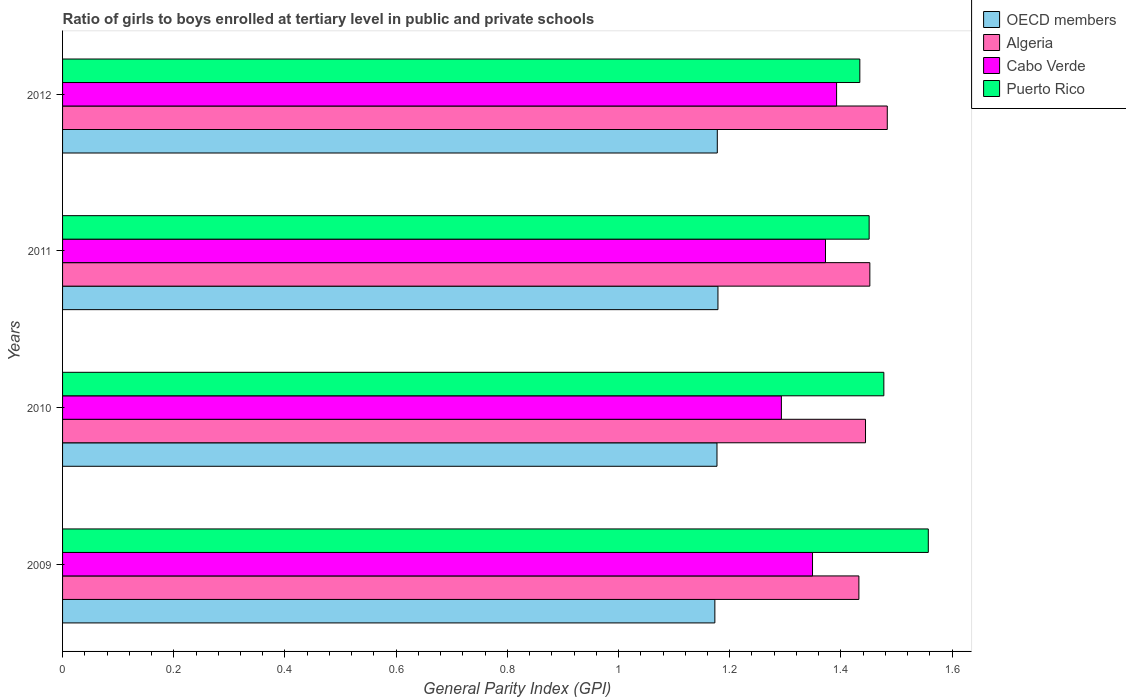How many groups of bars are there?
Give a very brief answer. 4. Are the number of bars on each tick of the Y-axis equal?
Your answer should be very brief. Yes. How many bars are there on the 1st tick from the bottom?
Ensure brevity in your answer.  4. What is the label of the 4th group of bars from the top?
Give a very brief answer. 2009. What is the general parity index in Cabo Verde in 2009?
Your answer should be very brief. 1.35. Across all years, what is the maximum general parity index in Puerto Rico?
Provide a succinct answer. 1.56. Across all years, what is the minimum general parity index in Algeria?
Keep it short and to the point. 1.43. In which year was the general parity index in Puerto Rico minimum?
Make the answer very short. 2012. What is the total general parity index in Algeria in the graph?
Give a very brief answer. 5.81. What is the difference between the general parity index in Puerto Rico in 2010 and that in 2011?
Keep it short and to the point. 0.03. What is the difference between the general parity index in Puerto Rico in 2009 and the general parity index in Cabo Verde in 2011?
Offer a very short reply. 0.18. What is the average general parity index in Puerto Rico per year?
Make the answer very short. 1.48. In the year 2012, what is the difference between the general parity index in Cabo Verde and general parity index in Algeria?
Keep it short and to the point. -0.09. What is the ratio of the general parity index in Cabo Verde in 2009 to that in 2011?
Make the answer very short. 0.98. What is the difference between the highest and the second highest general parity index in Cabo Verde?
Offer a terse response. 0.02. What is the difference between the highest and the lowest general parity index in Algeria?
Keep it short and to the point. 0.05. In how many years, is the general parity index in Algeria greater than the average general parity index in Algeria taken over all years?
Make the answer very short. 1. What does the 2nd bar from the top in 2010 represents?
Your answer should be very brief. Cabo Verde. What does the 1st bar from the bottom in 2010 represents?
Your response must be concise. OECD members. How many years are there in the graph?
Offer a very short reply. 4. What is the difference between two consecutive major ticks on the X-axis?
Offer a terse response. 0.2. Are the values on the major ticks of X-axis written in scientific E-notation?
Ensure brevity in your answer.  No. Where does the legend appear in the graph?
Provide a short and direct response. Top right. What is the title of the graph?
Give a very brief answer. Ratio of girls to boys enrolled at tertiary level in public and private schools. What is the label or title of the X-axis?
Ensure brevity in your answer.  General Parity Index (GPI). What is the label or title of the Y-axis?
Ensure brevity in your answer.  Years. What is the General Parity Index (GPI) in OECD members in 2009?
Your answer should be compact. 1.17. What is the General Parity Index (GPI) in Algeria in 2009?
Your answer should be compact. 1.43. What is the General Parity Index (GPI) of Cabo Verde in 2009?
Offer a very short reply. 1.35. What is the General Parity Index (GPI) of Puerto Rico in 2009?
Your response must be concise. 1.56. What is the General Parity Index (GPI) in OECD members in 2010?
Offer a terse response. 1.18. What is the General Parity Index (GPI) of Algeria in 2010?
Offer a very short reply. 1.44. What is the General Parity Index (GPI) of Cabo Verde in 2010?
Ensure brevity in your answer.  1.29. What is the General Parity Index (GPI) of Puerto Rico in 2010?
Your answer should be very brief. 1.48. What is the General Parity Index (GPI) in OECD members in 2011?
Your answer should be very brief. 1.18. What is the General Parity Index (GPI) of Algeria in 2011?
Your answer should be compact. 1.45. What is the General Parity Index (GPI) in Cabo Verde in 2011?
Your answer should be very brief. 1.37. What is the General Parity Index (GPI) in Puerto Rico in 2011?
Give a very brief answer. 1.45. What is the General Parity Index (GPI) in OECD members in 2012?
Make the answer very short. 1.18. What is the General Parity Index (GPI) of Algeria in 2012?
Provide a short and direct response. 1.48. What is the General Parity Index (GPI) of Cabo Verde in 2012?
Ensure brevity in your answer.  1.39. What is the General Parity Index (GPI) in Puerto Rico in 2012?
Give a very brief answer. 1.43. Across all years, what is the maximum General Parity Index (GPI) in OECD members?
Your answer should be compact. 1.18. Across all years, what is the maximum General Parity Index (GPI) of Algeria?
Offer a terse response. 1.48. Across all years, what is the maximum General Parity Index (GPI) in Cabo Verde?
Ensure brevity in your answer.  1.39. Across all years, what is the maximum General Parity Index (GPI) in Puerto Rico?
Offer a very short reply. 1.56. Across all years, what is the minimum General Parity Index (GPI) of OECD members?
Provide a short and direct response. 1.17. Across all years, what is the minimum General Parity Index (GPI) in Algeria?
Offer a very short reply. 1.43. Across all years, what is the minimum General Parity Index (GPI) of Cabo Verde?
Provide a short and direct response. 1.29. Across all years, what is the minimum General Parity Index (GPI) in Puerto Rico?
Ensure brevity in your answer.  1.43. What is the total General Parity Index (GPI) of OECD members in the graph?
Provide a succinct answer. 4.71. What is the total General Parity Index (GPI) in Algeria in the graph?
Provide a short and direct response. 5.81. What is the total General Parity Index (GPI) in Cabo Verde in the graph?
Your response must be concise. 5.41. What is the total General Parity Index (GPI) in Puerto Rico in the graph?
Provide a short and direct response. 5.92. What is the difference between the General Parity Index (GPI) of OECD members in 2009 and that in 2010?
Offer a very short reply. -0. What is the difference between the General Parity Index (GPI) in Algeria in 2009 and that in 2010?
Offer a very short reply. -0.01. What is the difference between the General Parity Index (GPI) in Cabo Verde in 2009 and that in 2010?
Keep it short and to the point. 0.06. What is the difference between the General Parity Index (GPI) in Puerto Rico in 2009 and that in 2010?
Keep it short and to the point. 0.08. What is the difference between the General Parity Index (GPI) of OECD members in 2009 and that in 2011?
Your answer should be very brief. -0.01. What is the difference between the General Parity Index (GPI) in Algeria in 2009 and that in 2011?
Keep it short and to the point. -0.02. What is the difference between the General Parity Index (GPI) in Cabo Verde in 2009 and that in 2011?
Make the answer very short. -0.02. What is the difference between the General Parity Index (GPI) in Puerto Rico in 2009 and that in 2011?
Give a very brief answer. 0.11. What is the difference between the General Parity Index (GPI) of OECD members in 2009 and that in 2012?
Your answer should be compact. -0. What is the difference between the General Parity Index (GPI) in Algeria in 2009 and that in 2012?
Offer a very short reply. -0.05. What is the difference between the General Parity Index (GPI) in Cabo Verde in 2009 and that in 2012?
Your response must be concise. -0.04. What is the difference between the General Parity Index (GPI) of Puerto Rico in 2009 and that in 2012?
Your answer should be very brief. 0.12. What is the difference between the General Parity Index (GPI) of OECD members in 2010 and that in 2011?
Your answer should be very brief. -0. What is the difference between the General Parity Index (GPI) in Algeria in 2010 and that in 2011?
Offer a very short reply. -0.01. What is the difference between the General Parity Index (GPI) in Cabo Verde in 2010 and that in 2011?
Your answer should be very brief. -0.08. What is the difference between the General Parity Index (GPI) in Puerto Rico in 2010 and that in 2011?
Make the answer very short. 0.03. What is the difference between the General Parity Index (GPI) in OECD members in 2010 and that in 2012?
Your response must be concise. -0. What is the difference between the General Parity Index (GPI) in Algeria in 2010 and that in 2012?
Your response must be concise. -0.04. What is the difference between the General Parity Index (GPI) of Cabo Verde in 2010 and that in 2012?
Your response must be concise. -0.1. What is the difference between the General Parity Index (GPI) of Puerto Rico in 2010 and that in 2012?
Keep it short and to the point. 0.04. What is the difference between the General Parity Index (GPI) in OECD members in 2011 and that in 2012?
Give a very brief answer. 0. What is the difference between the General Parity Index (GPI) in Algeria in 2011 and that in 2012?
Provide a short and direct response. -0.03. What is the difference between the General Parity Index (GPI) of Cabo Verde in 2011 and that in 2012?
Your answer should be compact. -0.02. What is the difference between the General Parity Index (GPI) in Puerto Rico in 2011 and that in 2012?
Your response must be concise. 0.02. What is the difference between the General Parity Index (GPI) in OECD members in 2009 and the General Parity Index (GPI) in Algeria in 2010?
Provide a succinct answer. -0.27. What is the difference between the General Parity Index (GPI) in OECD members in 2009 and the General Parity Index (GPI) in Cabo Verde in 2010?
Offer a very short reply. -0.12. What is the difference between the General Parity Index (GPI) of OECD members in 2009 and the General Parity Index (GPI) of Puerto Rico in 2010?
Keep it short and to the point. -0.3. What is the difference between the General Parity Index (GPI) in Algeria in 2009 and the General Parity Index (GPI) in Cabo Verde in 2010?
Ensure brevity in your answer.  0.14. What is the difference between the General Parity Index (GPI) in Algeria in 2009 and the General Parity Index (GPI) in Puerto Rico in 2010?
Provide a succinct answer. -0.04. What is the difference between the General Parity Index (GPI) of Cabo Verde in 2009 and the General Parity Index (GPI) of Puerto Rico in 2010?
Your answer should be very brief. -0.13. What is the difference between the General Parity Index (GPI) of OECD members in 2009 and the General Parity Index (GPI) of Algeria in 2011?
Keep it short and to the point. -0.28. What is the difference between the General Parity Index (GPI) in OECD members in 2009 and the General Parity Index (GPI) in Cabo Verde in 2011?
Provide a short and direct response. -0.2. What is the difference between the General Parity Index (GPI) in OECD members in 2009 and the General Parity Index (GPI) in Puerto Rico in 2011?
Offer a terse response. -0.28. What is the difference between the General Parity Index (GPI) in Algeria in 2009 and the General Parity Index (GPI) in Cabo Verde in 2011?
Your answer should be very brief. 0.06. What is the difference between the General Parity Index (GPI) of Algeria in 2009 and the General Parity Index (GPI) of Puerto Rico in 2011?
Your answer should be compact. -0.02. What is the difference between the General Parity Index (GPI) of Cabo Verde in 2009 and the General Parity Index (GPI) of Puerto Rico in 2011?
Offer a very short reply. -0.1. What is the difference between the General Parity Index (GPI) in OECD members in 2009 and the General Parity Index (GPI) in Algeria in 2012?
Your response must be concise. -0.31. What is the difference between the General Parity Index (GPI) of OECD members in 2009 and the General Parity Index (GPI) of Cabo Verde in 2012?
Offer a terse response. -0.22. What is the difference between the General Parity Index (GPI) in OECD members in 2009 and the General Parity Index (GPI) in Puerto Rico in 2012?
Your answer should be very brief. -0.26. What is the difference between the General Parity Index (GPI) of Algeria in 2009 and the General Parity Index (GPI) of Cabo Verde in 2012?
Provide a succinct answer. 0.04. What is the difference between the General Parity Index (GPI) in Algeria in 2009 and the General Parity Index (GPI) in Puerto Rico in 2012?
Ensure brevity in your answer.  -0. What is the difference between the General Parity Index (GPI) of Cabo Verde in 2009 and the General Parity Index (GPI) of Puerto Rico in 2012?
Make the answer very short. -0.09. What is the difference between the General Parity Index (GPI) of OECD members in 2010 and the General Parity Index (GPI) of Algeria in 2011?
Your answer should be very brief. -0.27. What is the difference between the General Parity Index (GPI) in OECD members in 2010 and the General Parity Index (GPI) in Cabo Verde in 2011?
Provide a short and direct response. -0.2. What is the difference between the General Parity Index (GPI) in OECD members in 2010 and the General Parity Index (GPI) in Puerto Rico in 2011?
Provide a short and direct response. -0.27. What is the difference between the General Parity Index (GPI) in Algeria in 2010 and the General Parity Index (GPI) in Cabo Verde in 2011?
Provide a succinct answer. 0.07. What is the difference between the General Parity Index (GPI) of Algeria in 2010 and the General Parity Index (GPI) of Puerto Rico in 2011?
Provide a short and direct response. -0.01. What is the difference between the General Parity Index (GPI) in Cabo Verde in 2010 and the General Parity Index (GPI) in Puerto Rico in 2011?
Give a very brief answer. -0.16. What is the difference between the General Parity Index (GPI) of OECD members in 2010 and the General Parity Index (GPI) of Algeria in 2012?
Provide a short and direct response. -0.31. What is the difference between the General Parity Index (GPI) in OECD members in 2010 and the General Parity Index (GPI) in Cabo Verde in 2012?
Offer a very short reply. -0.22. What is the difference between the General Parity Index (GPI) in OECD members in 2010 and the General Parity Index (GPI) in Puerto Rico in 2012?
Give a very brief answer. -0.26. What is the difference between the General Parity Index (GPI) of Algeria in 2010 and the General Parity Index (GPI) of Cabo Verde in 2012?
Make the answer very short. 0.05. What is the difference between the General Parity Index (GPI) of Algeria in 2010 and the General Parity Index (GPI) of Puerto Rico in 2012?
Keep it short and to the point. 0.01. What is the difference between the General Parity Index (GPI) of Cabo Verde in 2010 and the General Parity Index (GPI) of Puerto Rico in 2012?
Offer a very short reply. -0.14. What is the difference between the General Parity Index (GPI) of OECD members in 2011 and the General Parity Index (GPI) of Algeria in 2012?
Make the answer very short. -0.3. What is the difference between the General Parity Index (GPI) in OECD members in 2011 and the General Parity Index (GPI) in Cabo Verde in 2012?
Offer a terse response. -0.21. What is the difference between the General Parity Index (GPI) in OECD members in 2011 and the General Parity Index (GPI) in Puerto Rico in 2012?
Offer a very short reply. -0.26. What is the difference between the General Parity Index (GPI) of Algeria in 2011 and the General Parity Index (GPI) of Cabo Verde in 2012?
Make the answer very short. 0.06. What is the difference between the General Parity Index (GPI) in Algeria in 2011 and the General Parity Index (GPI) in Puerto Rico in 2012?
Provide a succinct answer. 0.02. What is the difference between the General Parity Index (GPI) in Cabo Verde in 2011 and the General Parity Index (GPI) in Puerto Rico in 2012?
Your answer should be very brief. -0.06. What is the average General Parity Index (GPI) of OECD members per year?
Provide a short and direct response. 1.18. What is the average General Parity Index (GPI) of Algeria per year?
Your response must be concise. 1.45. What is the average General Parity Index (GPI) in Cabo Verde per year?
Your answer should be very brief. 1.35. What is the average General Parity Index (GPI) of Puerto Rico per year?
Offer a very short reply. 1.48. In the year 2009, what is the difference between the General Parity Index (GPI) of OECD members and General Parity Index (GPI) of Algeria?
Make the answer very short. -0.26. In the year 2009, what is the difference between the General Parity Index (GPI) of OECD members and General Parity Index (GPI) of Cabo Verde?
Your response must be concise. -0.18. In the year 2009, what is the difference between the General Parity Index (GPI) of OECD members and General Parity Index (GPI) of Puerto Rico?
Your answer should be very brief. -0.38. In the year 2009, what is the difference between the General Parity Index (GPI) of Algeria and General Parity Index (GPI) of Cabo Verde?
Make the answer very short. 0.08. In the year 2009, what is the difference between the General Parity Index (GPI) in Algeria and General Parity Index (GPI) in Puerto Rico?
Give a very brief answer. -0.12. In the year 2009, what is the difference between the General Parity Index (GPI) in Cabo Verde and General Parity Index (GPI) in Puerto Rico?
Offer a terse response. -0.21. In the year 2010, what is the difference between the General Parity Index (GPI) in OECD members and General Parity Index (GPI) in Algeria?
Keep it short and to the point. -0.27. In the year 2010, what is the difference between the General Parity Index (GPI) of OECD members and General Parity Index (GPI) of Cabo Verde?
Your response must be concise. -0.12. In the year 2010, what is the difference between the General Parity Index (GPI) of OECD members and General Parity Index (GPI) of Puerto Rico?
Give a very brief answer. -0.3. In the year 2010, what is the difference between the General Parity Index (GPI) of Algeria and General Parity Index (GPI) of Cabo Verde?
Make the answer very short. 0.15. In the year 2010, what is the difference between the General Parity Index (GPI) in Algeria and General Parity Index (GPI) in Puerto Rico?
Make the answer very short. -0.03. In the year 2010, what is the difference between the General Parity Index (GPI) of Cabo Verde and General Parity Index (GPI) of Puerto Rico?
Keep it short and to the point. -0.18. In the year 2011, what is the difference between the General Parity Index (GPI) in OECD members and General Parity Index (GPI) in Algeria?
Your answer should be compact. -0.27. In the year 2011, what is the difference between the General Parity Index (GPI) of OECD members and General Parity Index (GPI) of Cabo Verde?
Give a very brief answer. -0.19. In the year 2011, what is the difference between the General Parity Index (GPI) of OECD members and General Parity Index (GPI) of Puerto Rico?
Make the answer very short. -0.27. In the year 2011, what is the difference between the General Parity Index (GPI) in Algeria and General Parity Index (GPI) in Cabo Verde?
Keep it short and to the point. 0.08. In the year 2011, what is the difference between the General Parity Index (GPI) of Algeria and General Parity Index (GPI) of Puerto Rico?
Make the answer very short. 0. In the year 2011, what is the difference between the General Parity Index (GPI) of Cabo Verde and General Parity Index (GPI) of Puerto Rico?
Make the answer very short. -0.08. In the year 2012, what is the difference between the General Parity Index (GPI) of OECD members and General Parity Index (GPI) of Algeria?
Ensure brevity in your answer.  -0.31. In the year 2012, what is the difference between the General Parity Index (GPI) of OECD members and General Parity Index (GPI) of Cabo Verde?
Offer a terse response. -0.21. In the year 2012, what is the difference between the General Parity Index (GPI) of OECD members and General Parity Index (GPI) of Puerto Rico?
Keep it short and to the point. -0.26. In the year 2012, what is the difference between the General Parity Index (GPI) of Algeria and General Parity Index (GPI) of Cabo Verde?
Give a very brief answer. 0.09. In the year 2012, what is the difference between the General Parity Index (GPI) of Algeria and General Parity Index (GPI) of Puerto Rico?
Your answer should be very brief. 0.05. In the year 2012, what is the difference between the General Parity Index (GPI) of Cabo Verde and General Parity Index (GPI) of Puerto Rico?
Your answer should be compact. -0.04. What is the ratio of the General Parity Index (GPI) in OECD members in 2009 to that in 2010?
Your answer should be compact. 1. What is the ratio of the General Parity Index (GPI) of Algeria in 2009 to that in 2010?
Your answer should be very brief. 0.99. What is the ratio of the General Parity Index (GPI) of Cabo Verde in 2009 to that in 2010?
Your answer should be compact. 1.04. What is the ratio of the General Parity Index (GPI) in Puerto Rico in 2009 to that in 2010?
Your response must be concise. 1.05. What is the ratio of the General Parity Index (GPI) in OECD members in 2009 to that in 2011?
Keep it short and to the point. 1. What is the ratio of the General Parity Index (GPI) of Algeria in 2009 to that in 2011?
Provide a short and direct response. 0.99. What is the ratio of the General Parity Index (GPI) in Cabo Verde in 2009 to that in 2011?
Provide a succinct answer. 0.98. What is the ratio of the General Parity Index (GPI) in Puerto Rico in 2009 to that in 2011?
Keep it short and to the point. 1.07. What is the ratio of the General Parity Index (GPI) in Algeria in 2009 to that in 2012?
Make the answer very short. 0.97. What is the ratio of the General Parity Index (GPI) of Cabo Verde in 2009 to that in 2012?
Give a very brief answer. 0.97. What is the ratio of the General Parity Index (GPI) in Puerto Rico in 2009 to that in 2012?
Your answer should be very brief. 1.09. What is the ratio of the General Parity Index (GPI) of OECD members in 2010 to that in 2011?
Make the answer very short. 1. What is the ratio of the General Parity Index (GPI) of Cabo Verde in 2010 to that in 2011?
Make the answer very short. 0.94. What is the ratio of the General Parity Index (GPI) of Puerto Rico in 2010 to that in 2011?
Offer a very short reply. 1.02. What is the ratio of the General Parity Index (GPI) of Algeria in 2010 to that in 2012?
Make the answer very short. 0.97. What is the ratio of the General Parity Index (GPI) of Cabo Verde in 2010 to that in 2012?
Your answer should be very brief. 0.93. What is the ratio of the General Parity Index (GPI) of Puerto Rico in 2010 to that in 2012?
Your answer should be very brief. 1.03. What is the ratio of the General Parity Index (GPI) in Algeria in 2011 to that in 2012?
Offer a very short reply. 0.98. What is the ratio of the General Parity Index (GPI) in Cabo Verde in 2011 to that in 2012?
Your answer should be compact. 0.99. What is the ratio of the General Parity Index (GPI) in Puerto Rico in 2011 to that in 2012?
Your answer should be very brief. 1.01. What is the difference between the highest and the second highest General Parity Index (GPI) of OECD members?
Your response must be concise. 0. What is the difference between the highest and the second highest General Parity Index (GPI) in Algeria?
Your answer should be very brief. 0.03. What is the difference between the highest and the second highest General Parity Index (GPI) of Puerto Rico?
Your answer should be very brief. 0.08. What is the difference between the highest and the lowest General Parity Index (GPI) of OECD members?
Give a very brief answer. 0.01. What is the difference between the highest and the lowest General Parity Index (GPI) of Algeria?
Make the answer very short. 0.05. What is the difference between the highest and the lowest General Parity Index (GPI) in Cabo Verde?
Offer a terse response. 0.1. What is the difference between the highest and the lowest General Parity Index (GPI) of Puerto Rico?
Give a very brief answer. 0.12. 